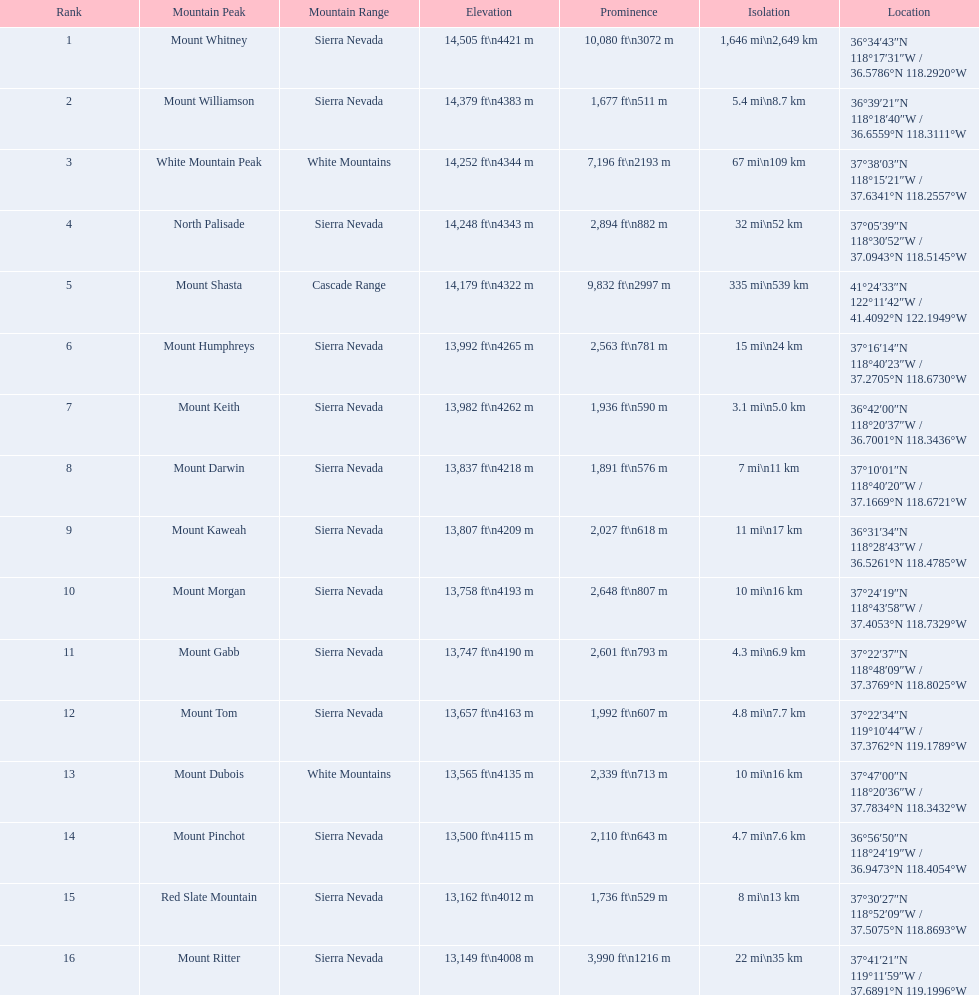What mountain peak comes after north palisade in terms of height? Mount Shasta. 